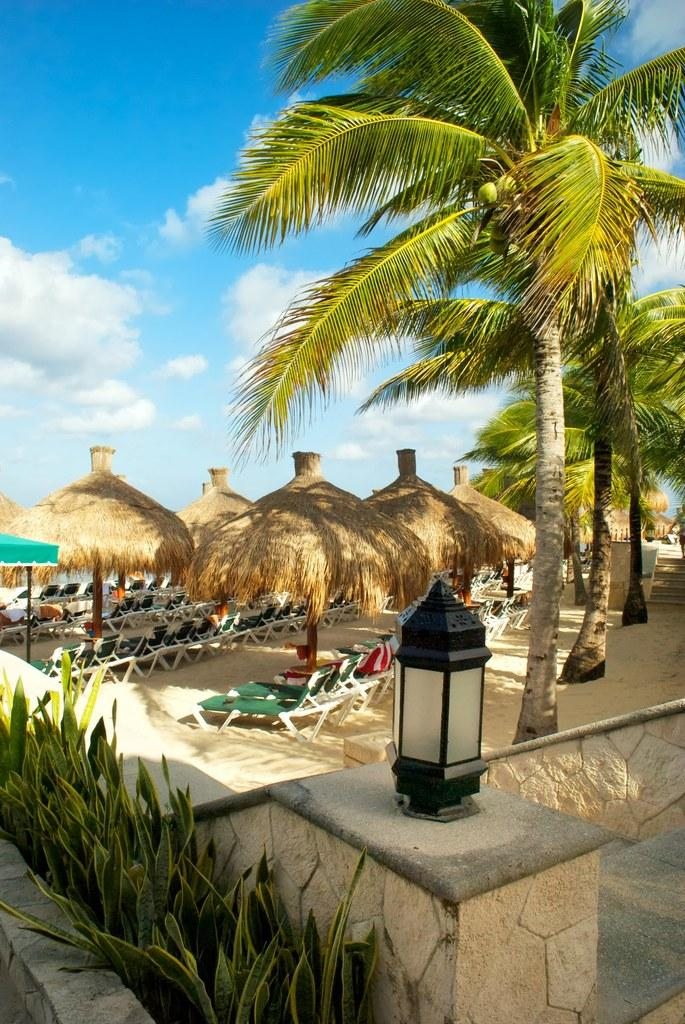What is located in the center of the image? There are trees, huts, lounge pool chairs, plants, a wall, a lamp, and a tent in the center of the image. What type of surface is visible in the center of the image? Sand is visible in the center of the image. What can be seen in the background of the image? The sky is visible in the background of the image, and clouds are present. How many legs does the connection have in the image? There is no connection present in the image, and therefore no legs can be counted. What type of approval is required for the tent in the image? The image does not show any need for approval, as it is a static representation of a scene. 